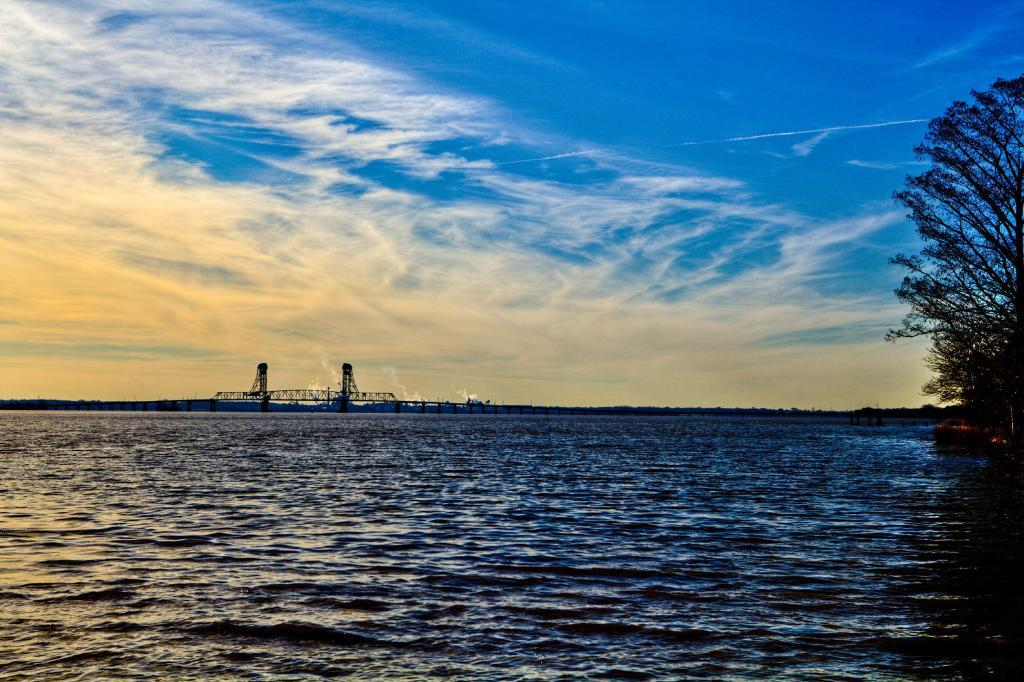What type of natural feature is at the bottom of the image? There is a river at the bottom of the image. What can be seen on the right side of the image? There are trees on the right side of the image. What structures are visible in the background of the image? There are towers in the background of the image. What is visible at the top of the image? The sky is visible at the top of the image. How many rings can be seen on the monkey's tail in the image? There is no monkey present in the image, and therefore no rings on its tail. Is there a window visible in the image? There is no window mentioned in the provided facts, and it is not visible in the image. 